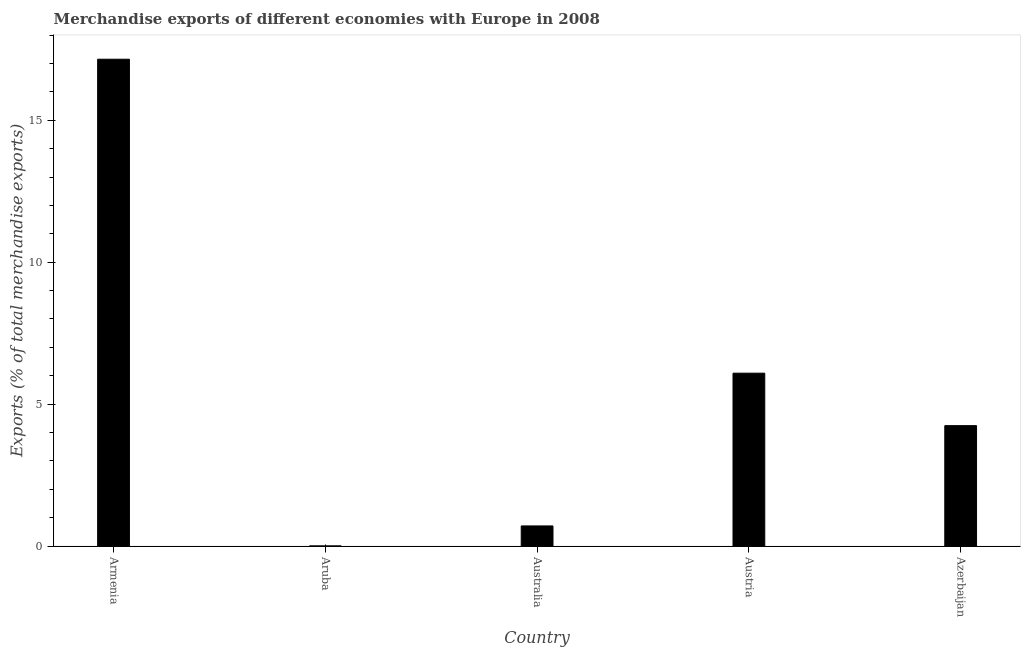What is the title of the graph?
Give a very brief answer. Merchandise exports of different economies with Europe in 2008. What is the label or title of the Y-axis?
Your response must be concise. Exports (% of total merchandise exports). What is the merchandise exports in Azerbaijan?
Keep it short and to the point. 4.24. Across all countries, what is the maximum merchandise exports?
Offer a terse response. 17.15. Across all countries, what is the minimum merchandise exports?
Provide a succinct answer. 0. In which country was the merchandise exports maximum?
Your answer should be very brief. Armenia. In which country was the merchandise exports minimum?
Make the answer very short. Aruba. What is the sum of the merchandise exports?
Give a very brief answer. 28.2. What is the difference between the merchandise exports in Australia and Austria?
Make the answer very short. -5.38. What is the average merchandise exports per country?
Make the answer very short. 5.64. What is the median merchandise exports?
Your response must be concise. 4.24. What is the ratio of the merchandise exports in Aruba to that in Austria?
Your answer should be compact. 0. Is the difference between the merchandise exports in Austria and Azerbaijan greater than the difference between any two countries?
Make the answer very short. No. What is the difference between the highest and the second highest merchandise exports?
Offer a very short reply. 11.06. What is the difference between the highest and the lowest merchandise exports?
Offer a very short reply. 17.15. In how many countries, is the merchandise exports greater than the average merchandise exports taken over all countries?
Provide a succinct answer. 2. What is the difference between two consecutive major ticks on the Y-axis?
Your answer should be very brief. 5. Are the values on the major ticks of Y-axis written in scientific E-notation?
Give a very brief answer. No. What is the Exports (% of total merchandise exports) in Armenia?
Your answer should be very brief. 17.15. What is the Exports (% of total merchandise exports) of Aruba?
Keep it short and to the point. 0. What is the Exports (% of total merchandise exports) of Australia?
Your response must be concise. 0.71. What is the Exports (% of total merchandise exports) of Austria?
Make the answer very short. 6.09. What is the Exports (% of total merchandise exports) in Azerbaijan?
Make the answer very short. 4.24. What is the difference between the Exports (% of total merchandise exports) in Armenia and Aruba?
Provide a short and direct response. 17.15. What is the difference between the Exports (% of total merchandise exports) in Armenia and Australia?
Your answer should be very brief. 16.44. What is the difference between the Exports (% of total merchandise exports) in Armenia and Austria?
Give a very brief answer. 11.06. What is the difference between the Exports (% of total merchandise exports) in Armenia and Azerbaijan?
Ensure brevity in your answer.  12.91. What is the difference between the Exports (% of total merchandise exports) in Aruba and Australia?
Provide a short and direct response. -0.71. What is the difference between the Exports (% of total merchandise exports) in Aruba and Austria?
Ensure brevity in your answer.  -6.09. What is the difference between the Exports (% of total merchandise exports) in Aruba and Azerbaijan?
Keep it short and to the point. -4.24. What is the difference between the Exports (% of total merchandise exports) in Australia and Austria?
Make the answer very short. -5.38. What is the difference between the Exports (% of total merchandise exports) in Australia and Azerbaijan?
Your answer should be very brief. -3.53. What is the difference between the Exports (% of total merchandise exports) in Austria and Azerbaijan?
Your answer should be very brief. 1.85. What is the ratio of the Exports (% of total merchandise exports) in Armenia to that in Aruba?
Your answer should be compact. 3960.53. What is the ratio of the Exports (% of total merchandise exports) in Armenia to that in Australia?
Your response must be concise. 24.14. What is the ratio of the Exports (% of total merchandise exports) in Armenia to that in Austria?
Provide a succinct answer. 2.82. What is the ratio of the Exports (% of total merchandise exports) in Armenia to that in Azerbaijan?
Keep it short and to the point. 4.04. What is the ratio of the Exports (% of total merchandise exports) in Aruba to that in Australia?
Your answer should be very brief. 0.01. What is the ratio of the Exports (% of total merchandise exports) in Aruba to that in Austria?
Provide a short and direct response. 0. What is the ratio of the Exports (% of total merchandise exports) in Australia to that in Austria?
Your answer should be compact. 0.12. What is the ratio of the Exports (% of total merchandise exports) in Australia to that in Azerbaijan?
Your answer should be compact. 0.17. What is the ratio of the Exports (% of total merchandise exports) in Austria to that in Azerbaijan?
Give a very brief answer. 1.44. 